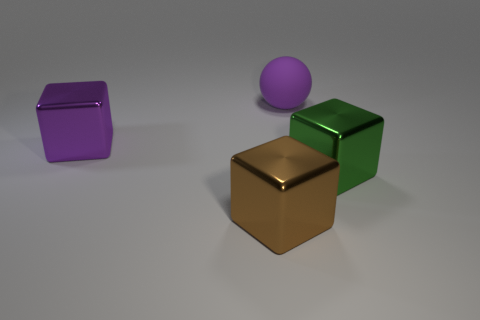Is there anything else that is made of the same material as the big purple ball?
Provide a succinct answer. No. Is the number of brown objects less than the number of big metal blocks?
Your answer should be compact. Yes. What is the shape of the object that is in front of the big green metal object?
Ensure brevity in your answer.  Cube. Does the matte object have the same color as the metal block behind the green metallic cube?
Ensure brevity in your answer.  Yes. Are there the same number of large purple shiny objects that are right of the purple sphere and blocks that are behind the big green metal thing?
Your answer should be compact. No. How many other things are there of the same size as the brown object?
Give a very brief answer. 3. Do the brown object and the purple object that is to the left of the ball have the same material?
Give a very brief answer. Yes. Are there any large yellow matte things of the same shape as the brown shiny object?
Make the answer very short. No. There is a sphere that is the same size as the brown shiny cube; what is its material?
Make the answer very short. Rubber. What number of cyan cylinders are the same material as the green cube?
Provide a succinct answer. 0. 